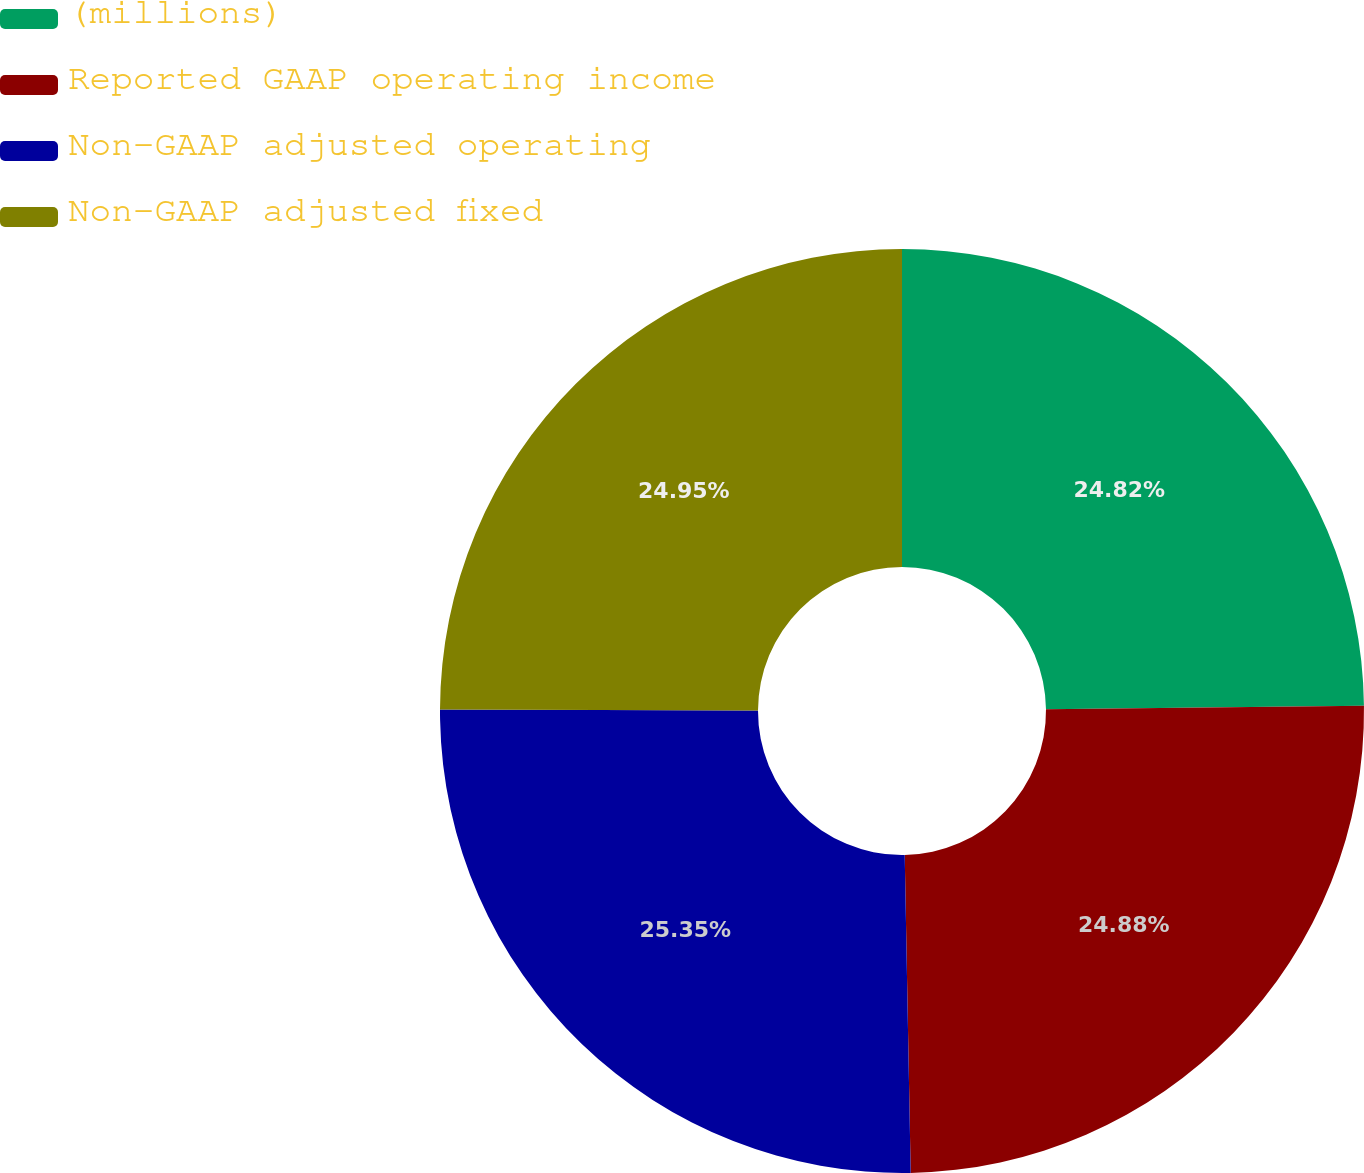Convert chart. <chart><loc_0><loc_0><loc_500><loc_500><pie_chart><fcel>(millions)<fcel>Reported GAAP operating income<fcel>Non-GAAP adjusted operating<fcel>Non-GAAP adjusted fixed<nl><fcel>24.82%<fcel>24.88%<fcel>25.35%<fcel>24.95%<nl></chart> 